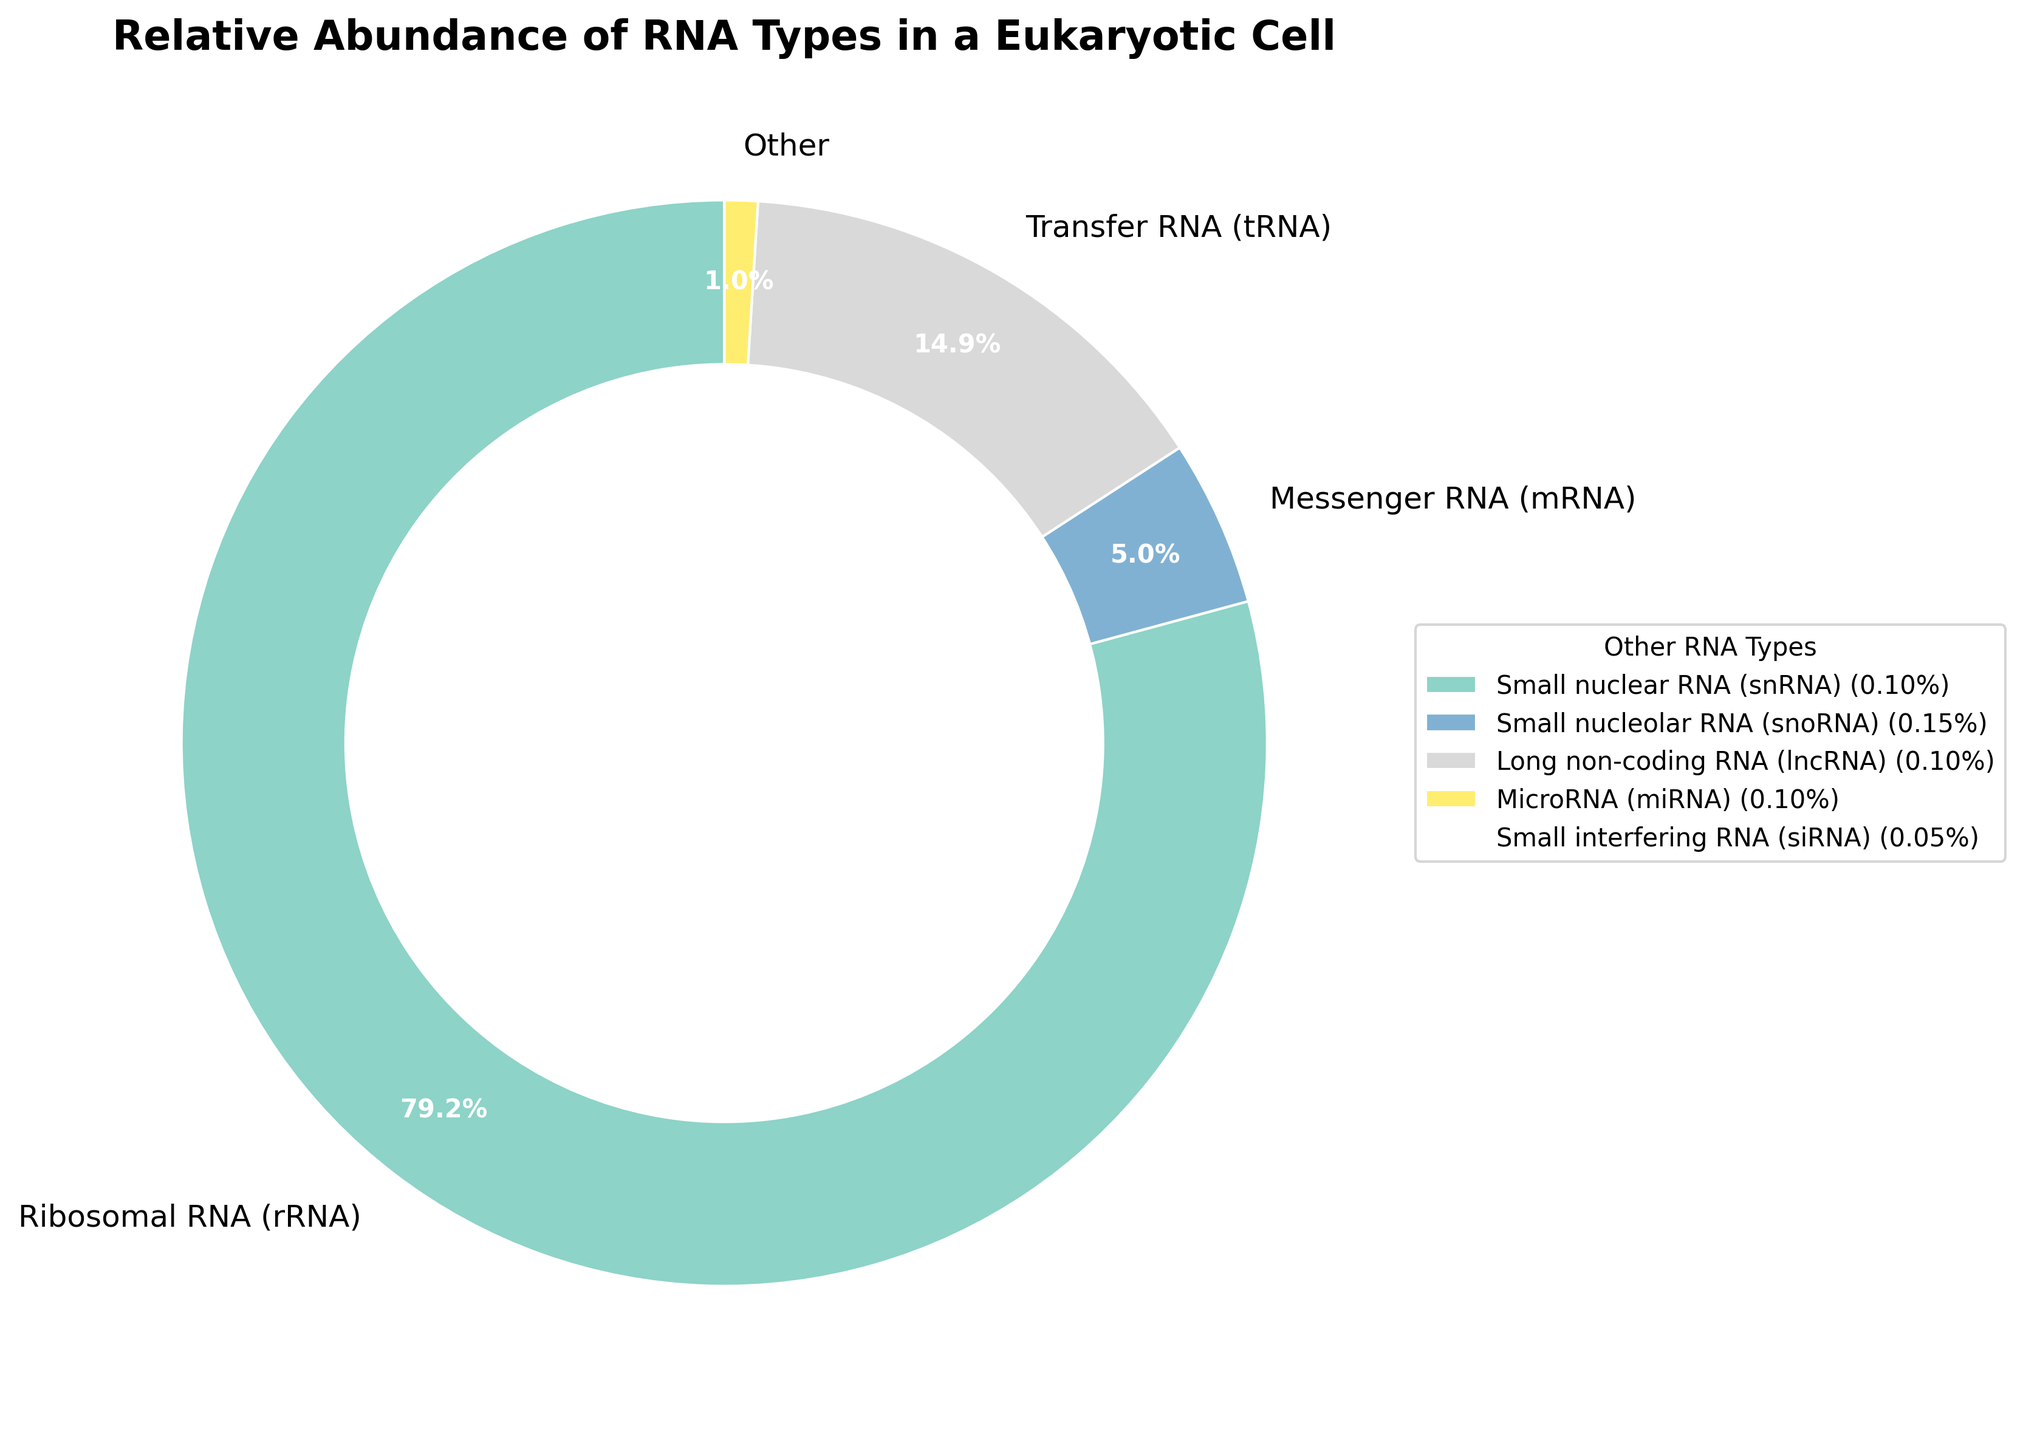Which type of RNA has the highest relative abundance? The pie chart shows that Ribosomal RNA (rRNA) occupies the largest section. By referring to the figure, it's evident that rRNA has the highest percentage.
Answer: rRNA What is the combined percentage of Messenger RNA (mRNA) and Transfer RNA (tRNA)? From the chart, mRNA is 5% and tRNA is 15%. Adding these two values gives us 5% + 15% = 20%.
Answer: 20% Which category does the 'Other' wedge represent and how much percentage does it sum up to? The 'Other' category represents RNA types with percentages smaller than 1%. Summing up these small percentages yields 0.1% + 0.15% + 0.1% + 0.1% + 0.05% + 0.1% + 0.2% + 0.05% + 0.05% = 0.9%. The chart represents this as the 'Other' wedge.
Answer: 0.9% What are the key colors used to differentiate the largest and smallest RNA types in the chart? The largest wedge (rRNA) appears yellowish-tan and the small contributions labeled 'Other' are aggregately depicted using various softer shades like light blue and green. By visually analyzing the color coding, this conclusion can be drawn.
Answer: Yellowish-tan for rRNA, light blue and green for 'Other' Which type of RNA has an almost negligible percentage and what is its value? The pie chart shows several RNA types with small percentages. The smallest ones among them are Small interfering RNA (siRNA) and Small Cajal body-specific RNA (scaRNA) each with 0.05%.
Answer: siRNA and scaRNA at 0.05% How does the percentage of Ribosomal RNA (rRNA) compare to that of the 'Other' category combined? The pie chart shows that rRNA has a relative abundance of 80%, while the 'Other' category sums up to 0.9%. Comparatively, rRNA has a percentage significantly higher than 'Other'.
Answer: rRNA is much higher What percentage would the pie chart need to adjust for if the visually displayed percentages did not include the 'Other' category? If 'Other' category is removed, the chart adjustments include allocating 0.9% to the remaining categories, slightly modifying each other section. Exact calculations were required to redistribute, ensuring sum remains 100%.
Answer: Redistribution needed to total 100% If Long non-coding RNA (lncRNA) and MicroRNA (miRNA) were shown separately instead of in 'Other,' would they still be the smallest components individually? Both lncRNA and miRNA each have a percentage of 0.1%, which, if displayed individually, would still be among the smallest sections aside from siRNA and scaRNA at 0.05%.
Answer: Yes What can be concluded about the relative abundance of Piwi-interacting RNA (piRNA) in comparison to the sum of mRNA and tRNA? Comparing values, piRNA has a much smaller percentage at 0.1% in the 'Other' category, while mRNA and tRNA combined total to 20%. Thus, piRNA's percentage is negligible compared to mRNA and tRNA summed up.
Answer: Much smaller 